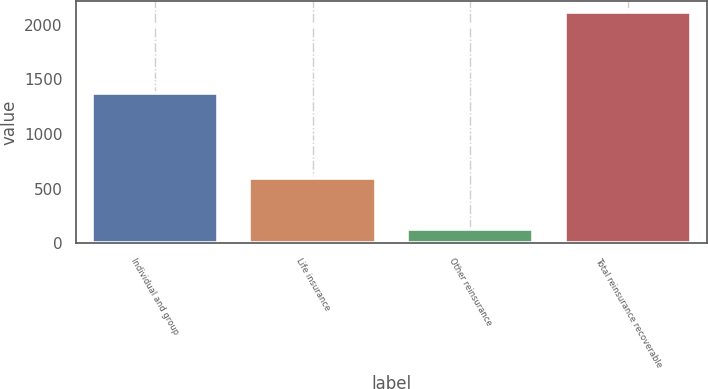Convert chart to OTSL. <chart><loc_0><loc_0><loc_500><loc_500><bar_chart><fcel>Individual and group<fcel>Life insurance<fcel>Other reinsurance<fcel>Total reinsurance recoverable<nl><fcel>1378<fcel>602<fcel>135<fcel>2115<nl></chart> 